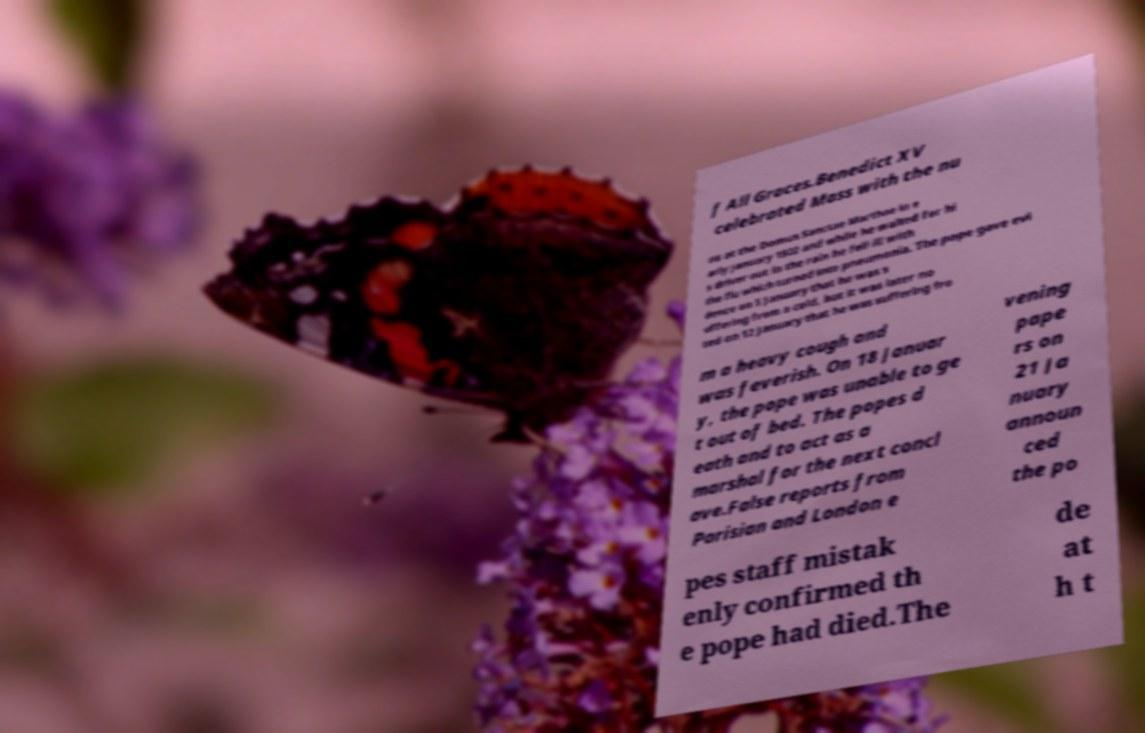What messages or text are displayed in this image? I need them in a readable, typed format. f All Graces.Benedict XV celebrated Mass with the nu ns at the Domus Sanctae Marthae in e arly January 1922 and while he waited for hi s driver out in the rain he fell ill with the flu which turned into pneumonia. The pope gave evi dence on 5 January that he was s uffering from a cold, but it was later no ted on 12 January that he was suffering fro m a heavy cough and was feverish. On 18 Januar y, the pope was unable to ge t out of bed. The popes d eath and to act as a marshal for the next concl ave.False reports from Parisian and London e vening pape rs on 21 Ja nuary announ ced the po pes staff mistak enly confirmed th e pope had died.The de at h t 